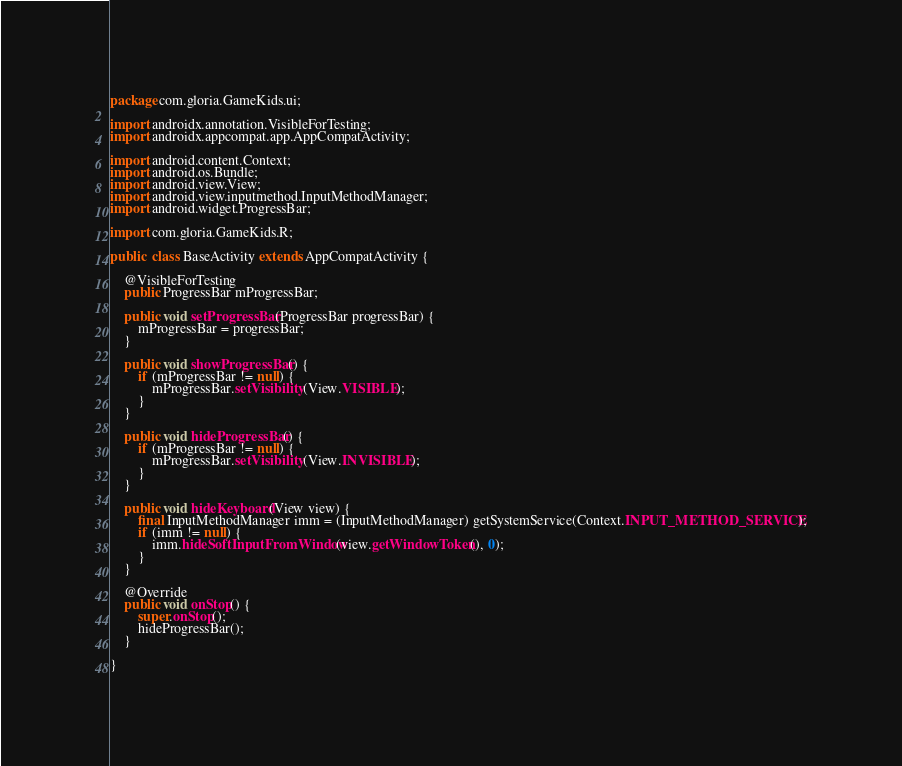Convert code to text. <code><loc_0><loc_0><loc_500><loc_500><_Java_>package com.gloria.GameKids.ui;

import androidx.annotation.VisibleForTesting;
import androidx.appcompat.app.AppCompatActivity;

import android.content.Context;
import android.os.Bundle;
import android.view.View;
import android.view.inputmethod.InputMethodManager;
import android.widget.ProgressBar;

import com.gloria.GameKids.R;

public  class BaseActivity extends AppCompatActivity {

    @VisibleForTesting
    public ProgressBar mProgressBar;

    public void setProgressBar(ProgressBar progressBar) {
        mProgressBar = progressBar;
    }

    public void showProgressBar() {
        if (mProgressBar != null) {
            mProgressBar.setVisibility(View.VISIBLE);
        }
    }

    public void hideProgressBar() {
        if (mProgressBar != null) {
            mProgressBar.setVisibility(View.INVISIBLE);
        }
    }

    public void hideKeyboard(View view) {
        final InputMethodManager imm = (InputMethodManager) getSystemService(Context.INPUT_METHOD_SERVICE);
        if (imm != null) {
            imm.hideSoftInputFromWindow(view.getWindowToken(), 0);
        }
    }

    @Override
    public void onStop() {
        super.onStop();
        hideProgressBar();
    }

}</code> 